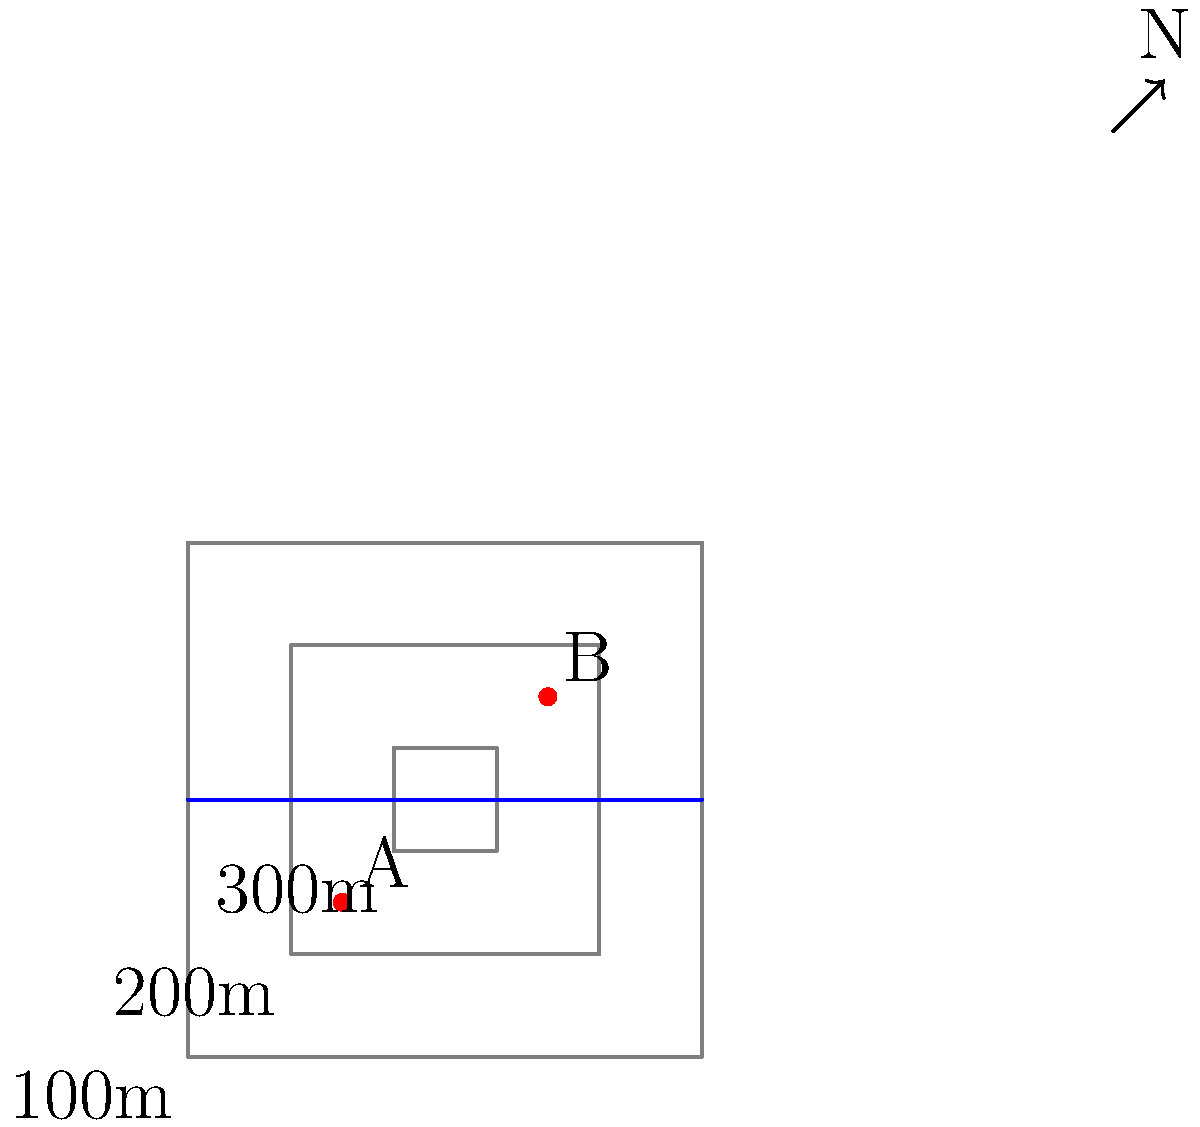Based on the topographic map provided, which route would be most suitable for a peacekeeping convoy traveling from point A to point B, considering both elevation changes and water obstacles? To determine the most suitable route for the peacekeeping convoy, we need to analyze the topographic map and consider both elevation changes and water obstacles. Let's break down the analysis step-by-step:

1. Elevation analysis:
   - The map shows three contour lines representing different elevations.
   - The outermost contour is at 100m, the middle at 200m, and the innermost at 300m.
   - Point A is located between the 200m and 300m contours.
   - Point B is located between the 200m and 300m contours.

2. Water obstacle:
   - There is a river running horizontally across the center of the map.

3. Possible routes:
   a. Direct route: This would involve crossing the 300m elevation and then descending to cross the river.
   b. Northern route: This would involve staying at a lower elevation (between 200m and 300m) but would require crossing the river at its widest point.
   c. Southern route: This would involve staying at a lower elevation (between 200m and 300m) and crossing the river at its narrowest point.

4. Route evaluation:
   - The direct route would require the most elevation change and crossing the river at a medium width.
   - The northern route would have less elevation change but requires crossing the widest part of the river.
   - The southern route offers the least elevation change and allows crossing the river at its narrowest point.

5. Conclusion:
   The southern route is the most suitable for the peacekeeping convoy because:
   - It minimizes elevation changes, reducing vehicle strain and fuel consumption.
   - It allows crossing the river at its narrowest point, which is likely to be the easiest and safest crossing.
Answer: Southern route 